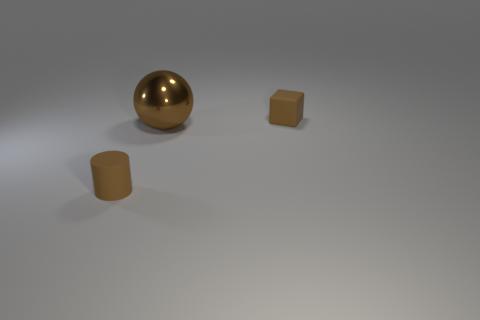Add 2 brown objects. How many objects exist? 5 Subtract all cubes. How many objects are left? 2 Subtract all tiny cyan spheres. Subtract all cubes. How many objects are left? 2 Add 3 small cylinders. How many small cylinders are left? 4 Add 3 matte blocks. How many matte blocks exist? 4 Subtract 0 cyan spheres. How many objects are left? 3 